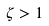Convert formula to latex. <formula><loc_0><loc_0><loc_500><loc_500>\zeta > 1</formula> 